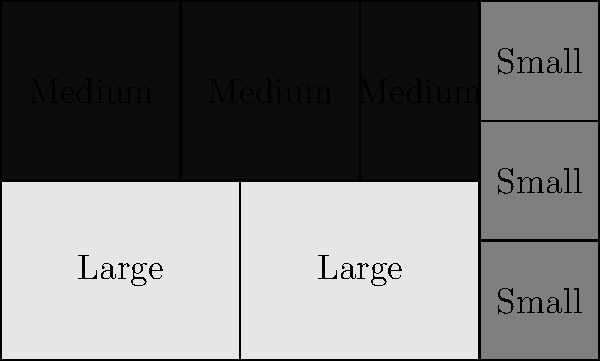As a logistics manager, you're tasked with optimizing warehouse storage. Given a rectangular warehouse floor measuring 10 units wide by 6 units deep, and three types of boxes (large: 4x3, medium: 2x3, small: 2x2), what is the maximum number of boxes that can be stored while utilizing the entire floor space? To solve this problem, we'll follow these steps:

1. Calculate the total area of the warehouse floor:
   $Area = 10 \times 6 = 60$ square units

2. Determine the area of each box type:
   - Large box: $4 \times 3 = 12$ square units
   - Medium box: $2 \times 3 = 6$ square units
   - Small box: $2 \times 2 = 4$ square units

3. Analyze the optimal arrangement:
   - Two large boxes can fit side by side, covering $2 \times 12 = 24$ square units
   - Three medium boxes can fit in the remaining vertical space, covering $3 \times 6 = 18$ square units
   - Three small boxes can fit in the remaining column, covering $3 \times 4 = 12$ square units

4. Verify that all space is utilized:
   $24 + 18 + 12 = 54$ square units, which matches the total area

5. Count the total number of boxes:
   - 2 large boxes
   - 3 medium boxes
   - 3 small boxes

6. Sum up the total number of boxes:
   $2 + 3 + 3 = 8$ boxes

Therefore, the maximum number of boxes that can be stored while utilizing the entire floor space is 8.
Answer: 8 boxes 